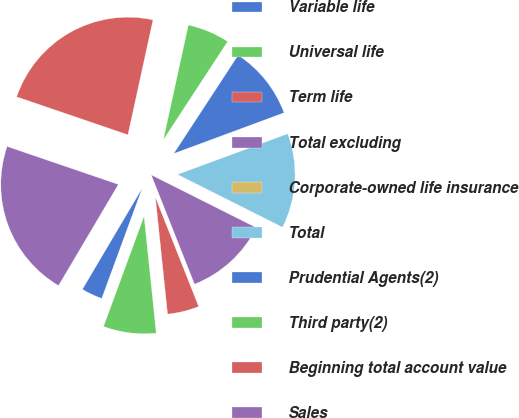Convert chart to OTSL. <chart><loc_0><loc_0><loc_500><loc_500><pie_chart><fcel>Variable life<fcel>Universal life<fcel>Term life<fcel>Total excluding<fcel>Corporate-owned life insurance<fcel>Total<fcel>Prudential Agents(2)<fcel>Third party(2)<fcel>Beginning total account value<fcel>Sales<nl><fcel>2.9%<fcel>7.25%<fcel>4.35%<fcel>11.59%<fcel>0.0%<fcel>13.04%<fcel>10.14%<fcel>5.8%<fcel>23.18%<fcel>21.73%<nl></chart> 